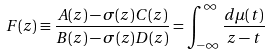<formula> <loc_0><loc_0><loc_500><loc_500>F ( z ) \equiv \frac { A ( z ) - \sigma ( z ) C ( z ) } { B ( z ) - \sigma ( z ) D ( z ) } = \int _ { - \infty } ^ { \infty } \frac { d \mu ( t ) } { z - t }</formula> 